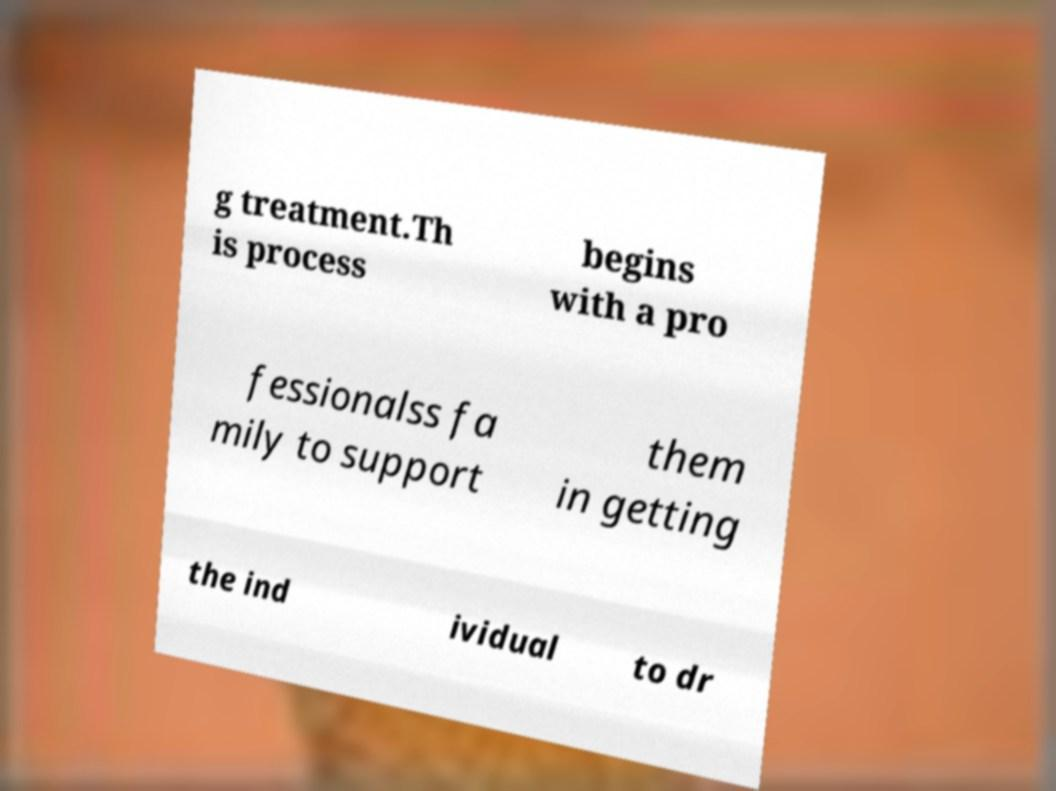What messages or text are displayed in this image? I need them in a readable, typed format. g treatment.Th is process begins with a pro fessionalss fa mily to support them in getting the ind ividual to dr 